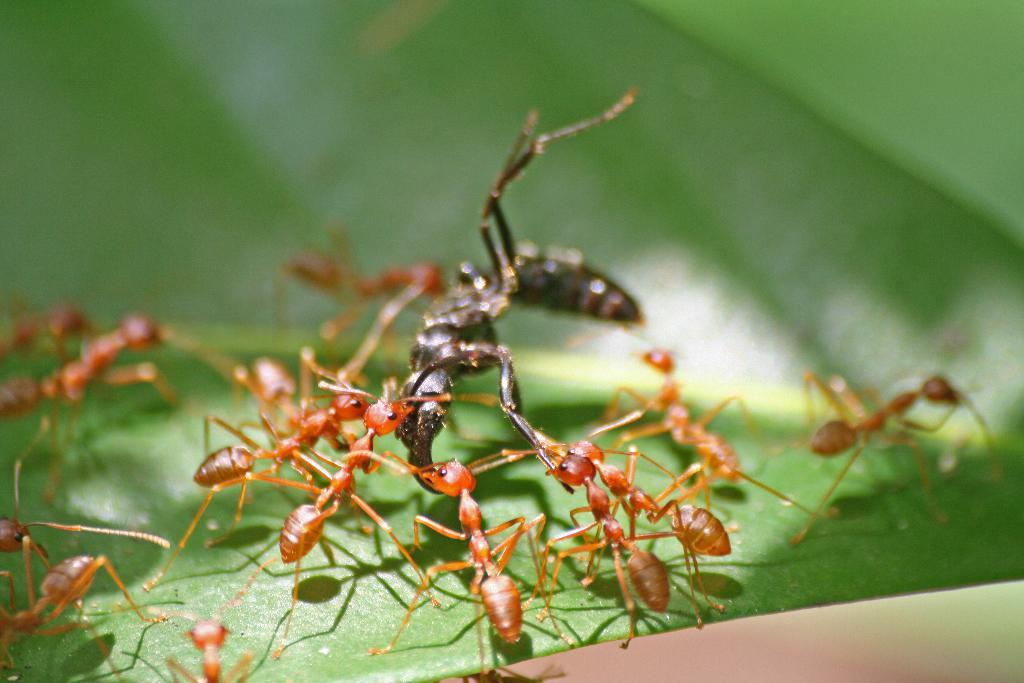What is the main subject of the image? The main subject of the image is ants on a green leaf. Can you describe the background of the image? The background of the image has a blurred view. What type of bed can be seen in the image? There is no bed present in the image; it features ants on a green leaf with a blurred background. How do the ants say good-bye to each other in the image? Ants do not have the ability to say good-bye, and there is no indication of any interaction between the ants in the image. 